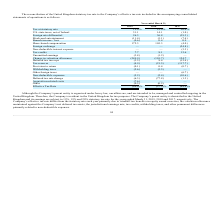According to Mimecast Limited's financial document, Which country controls the company's affairs? According to the financial document, United Kingdom. The relevant text states: "The reconciliation of the United Kingdom statutory tax rate to the Company’s effective tax rate included in the accompanying consolidated The reconciliation of the United Kingdom statutory tax rate to..." Also, What is the reason for the company's effective tax to differ from the statutory rate? primarily due to windfall tax benefits on equity award exercises, the valuation allowance maintained against the Company’s net deferred tax assets, the jurisdictional earnings mix, tax credits, withholding taxes, and other permanent differences primarily related to non-deductible expenses.. The document states: "tax rate differs from the statutory rate each year primarily due to windfall tax benefits on equity award exercises, the valuation allowance maintaine..." Also, What was the Tax at statutory rate in 2019, 2018 and 2017 respectively? The document contains multiple relevant values: 19.0%, 19.0%, 20.0%. From the document: "Tax at statutory rate 19.0% 19.0% 20.0% Tax at statutory rate 19.0% 19.0% 20.0%..." Also, can you calculate: What was the change in the U.S. state taxes, net of federal from 2018 to 2019? Based on the calculation: 31.1 - 14.1, the result is 17 (percentage). This is based on the information: "U.S. state taxes, net of federal 31.1 14.1 (1.0) U.S. state taxes, net of federal 31.1 14.1 (1.0)..." The key data points involved are: 14.1, 31.1. Also, can you calculate: What was the average Share-based compensation between 2017-2019? To answer this question, I need to perform calculations using the financial data. The calculation is: (172.3 + 105.3 - 4.0) / 3, which equals 91.2 (percentage). This is based on the information: "Share-based compensation 172.3 105.3 (4.0) Share-based compensation 172.3 105.3 (4.0) Share-based compensation 172.3 105.3 (4.0)..." The key data points involved are: 105.3, 172.3, 4.0. Additionally, In which year was Tax credits less than 10.0? The document shows two values: 2019 and 2018. Locate and analyze tax credits in row 11. From the document: "2019 2018 2017 2019 2018 2017..." 